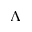<formula> <loc_0><loc_0><loc_500><loc_500>\Lambda</formula> 